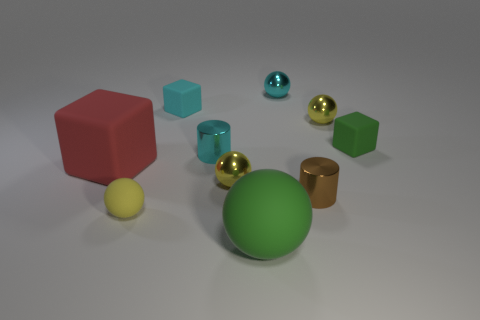The tiny cyan object that is made of the same material as the cyan cylinder is what shape? sphere 